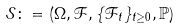Convert formula to latex. <formula><loc_0><loc_0><loc_500><loc_500>\mathcal { S } \colon = \left ( \Omega , \mathcal { F } , \{ \mathcal { F } _ { t } \} _ { t \geq 0 } , \mathbb { P } \right )</formula> 